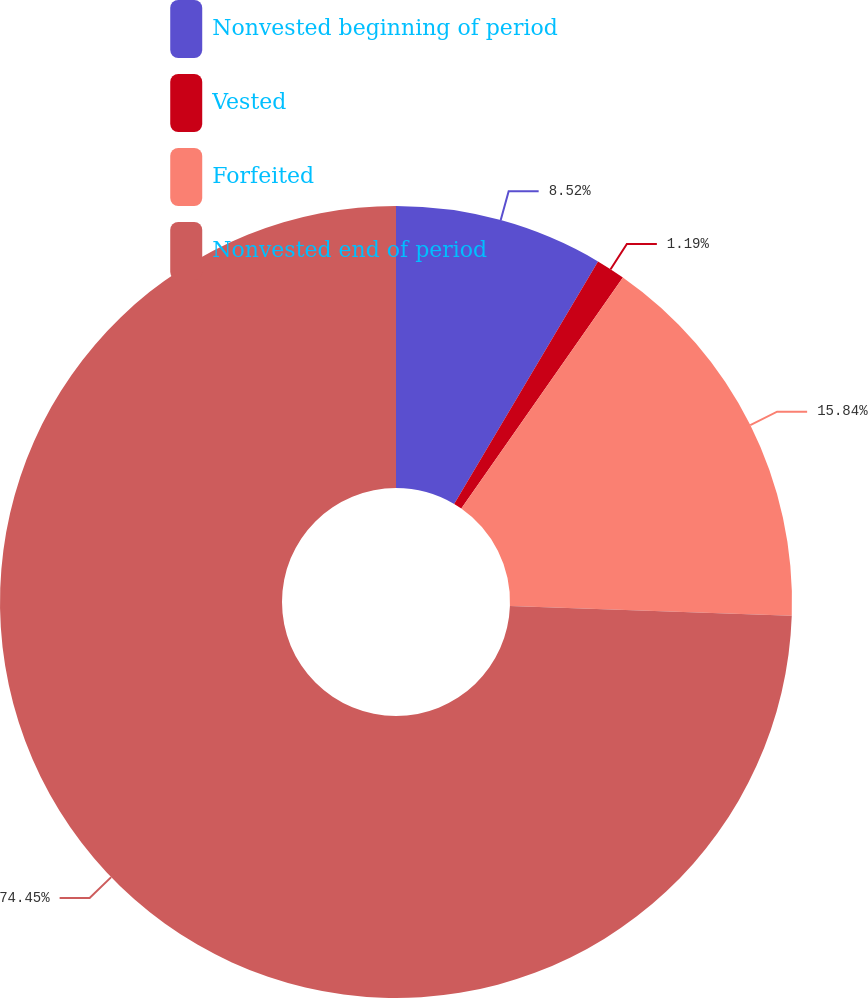Convert chart to OTSL. <chart><loc_0><loc_0><loc_500><loc_500><pie_chart><fcel>Nonvested beginning of period<fcel>Vested<fcel>Forfeited<fcel>Nonvested end of period<nl><fcel>8.52%<fcel>1.19%<fcel>15.84%<fcel>74.45%<nl></chart> 